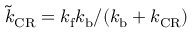<formula> <loc_0><loc_0><loc_500><loc_500>\tilde { k } _ { C R } = k _ { f } k _ { b } / ( k _ { b } + k _ { C R } )</formula> 